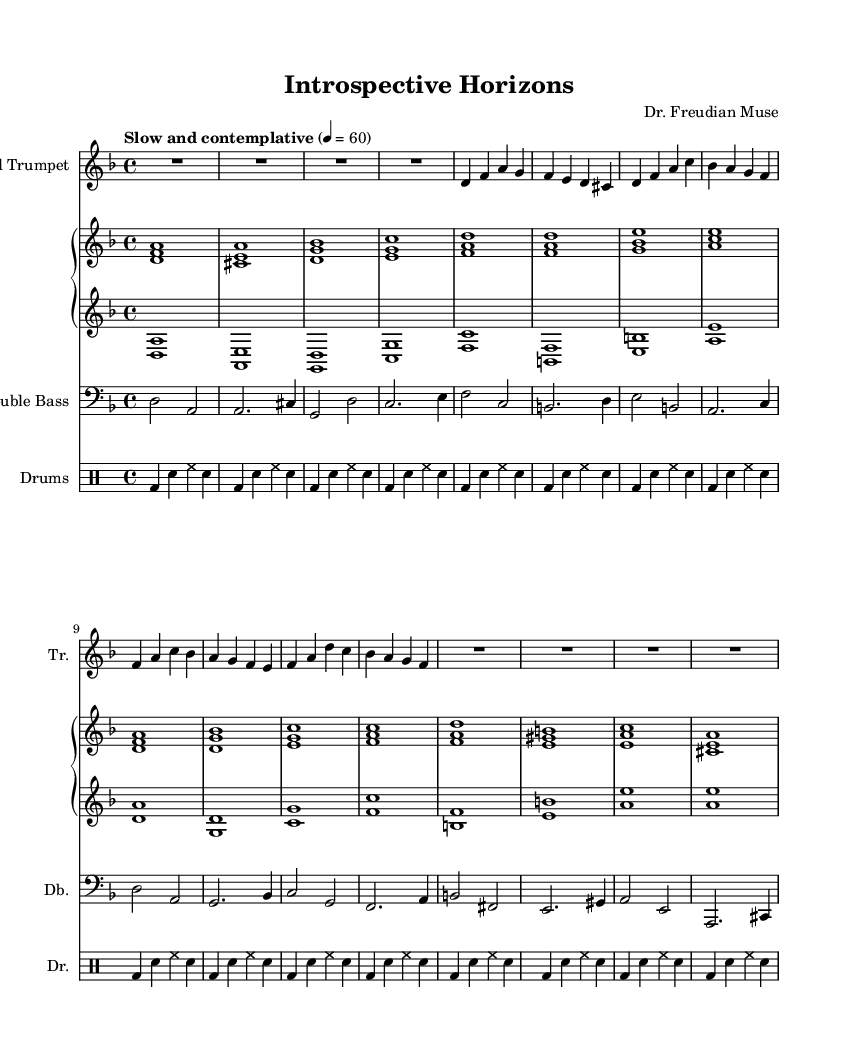What is the key signature of this music? The key signature is indicated by the number of sharps or flats on the staff. In this score, there are no sharps or flats shown, indicating that it is in D minor, which is the relative minor of F major and has one flat.
Answer: D minor What is the time signature of this piece? The time signature is shown at the beginning of the score. Here, it is indicated as 4/4, meaning there are four beats in each measure and the quarter note receives one beat.
Answer: 4/4 What tempo marking is given for this score? The tempo marking is provided above the music staff. It states "Slow and contemplative," which indicates the desired pace for performing the piece.
Answer: Slow and contemplative How many measures does the trumpet part contain? To find the number of measures in the trumpet part, you count the distinct segments separated by vertical lines in the music notation. The trumpet part has 8 measures.
Answer: 8 Describe the texture of the music in terms of instrument combination. The texture is described by analyzing the instruments written in the score. There is a muted trumpet, piano (both right and left hand), double bass, and drums, creating a rich collaboration characteristic of jazz.
Answer: Muted trumpet, piano, double bass, drums Which musical style does this piece represent? The musical style is indicated by the instrumentations, tempo, and overall feel of the composition. This piece showcases features typical of "cool jazz," aimed at creating relaxing and reflective soundscapes.
Answer: Cool jazz What instrument plays the bass line? The instrument playing the bass line is identified by the staff it is written on. In this score, the bass line is designated for the "Double Bass," which is the instrument commonly used for bass parts in jazz.
Answer: Double Bass 